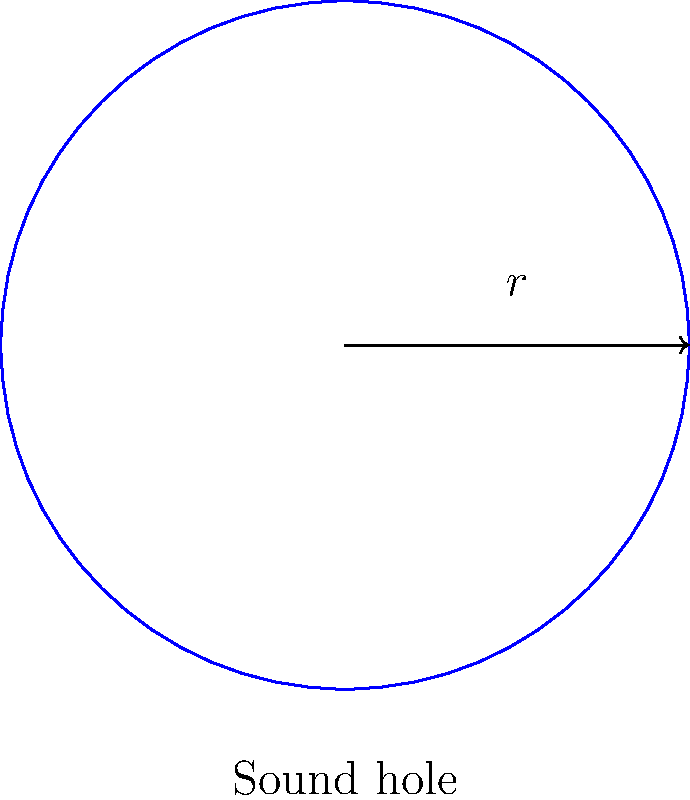As a guitar expert, you know that the size of a guitar's sound hole affects its acoustics. If a circular sound hole has a diameter of 4 inches, calculate its area and explain how this might impact the guitar's sound. How would doubling the radius change the area and potentially alter the acoustics? Let's approach this step-by-step:

1) First, let's calculate the area of the original sound hole:
   - Diameter = 4 inches, so radius = 2 inches
   - Area of a circle is given by the formula $A = \pi r^2$
   - $A = \pi (2)^2 = 4\pi \approx 12.57$ square inches

2) Now, let's consider doubling the radius:
   - New radius = 4 inches
   - New area $A_{new} = \pi (4)^2 = 16\pi \approx 50.27$ square inches

3) Impact on acoustics:
   - The original sound hole (12.57 sq in) allows for a balanced output of mid and high frequencies.
   - Doubling the radius quadruples the area (50.27 sq in), which would significantly alter the guitar's sound:
     a) Increased bass response due to more air movement
     b) Potential loss of projection and focus in the mid-range
     c) Possible decrease in overall volume due to reduced body resonance

4) The relationship between radius and area:
   - When we doubled the radius, the area increased by a factor of 4
   - This is because area is proportional to the square of the radius ($A \propto r^2$)

In conclusion, while a larger sound hole can enhance bass response and overall volume to a point, it may compromise other aspects of the guitar's tone. The optimal size depends on the specific guitar design and desired sound characteristics.
Answer: Original area: $12.57$ sq in. Doubled radius area: $50.27$ sq in. Larger hole increases bass, may reduce mid-range projection and overall volume. 